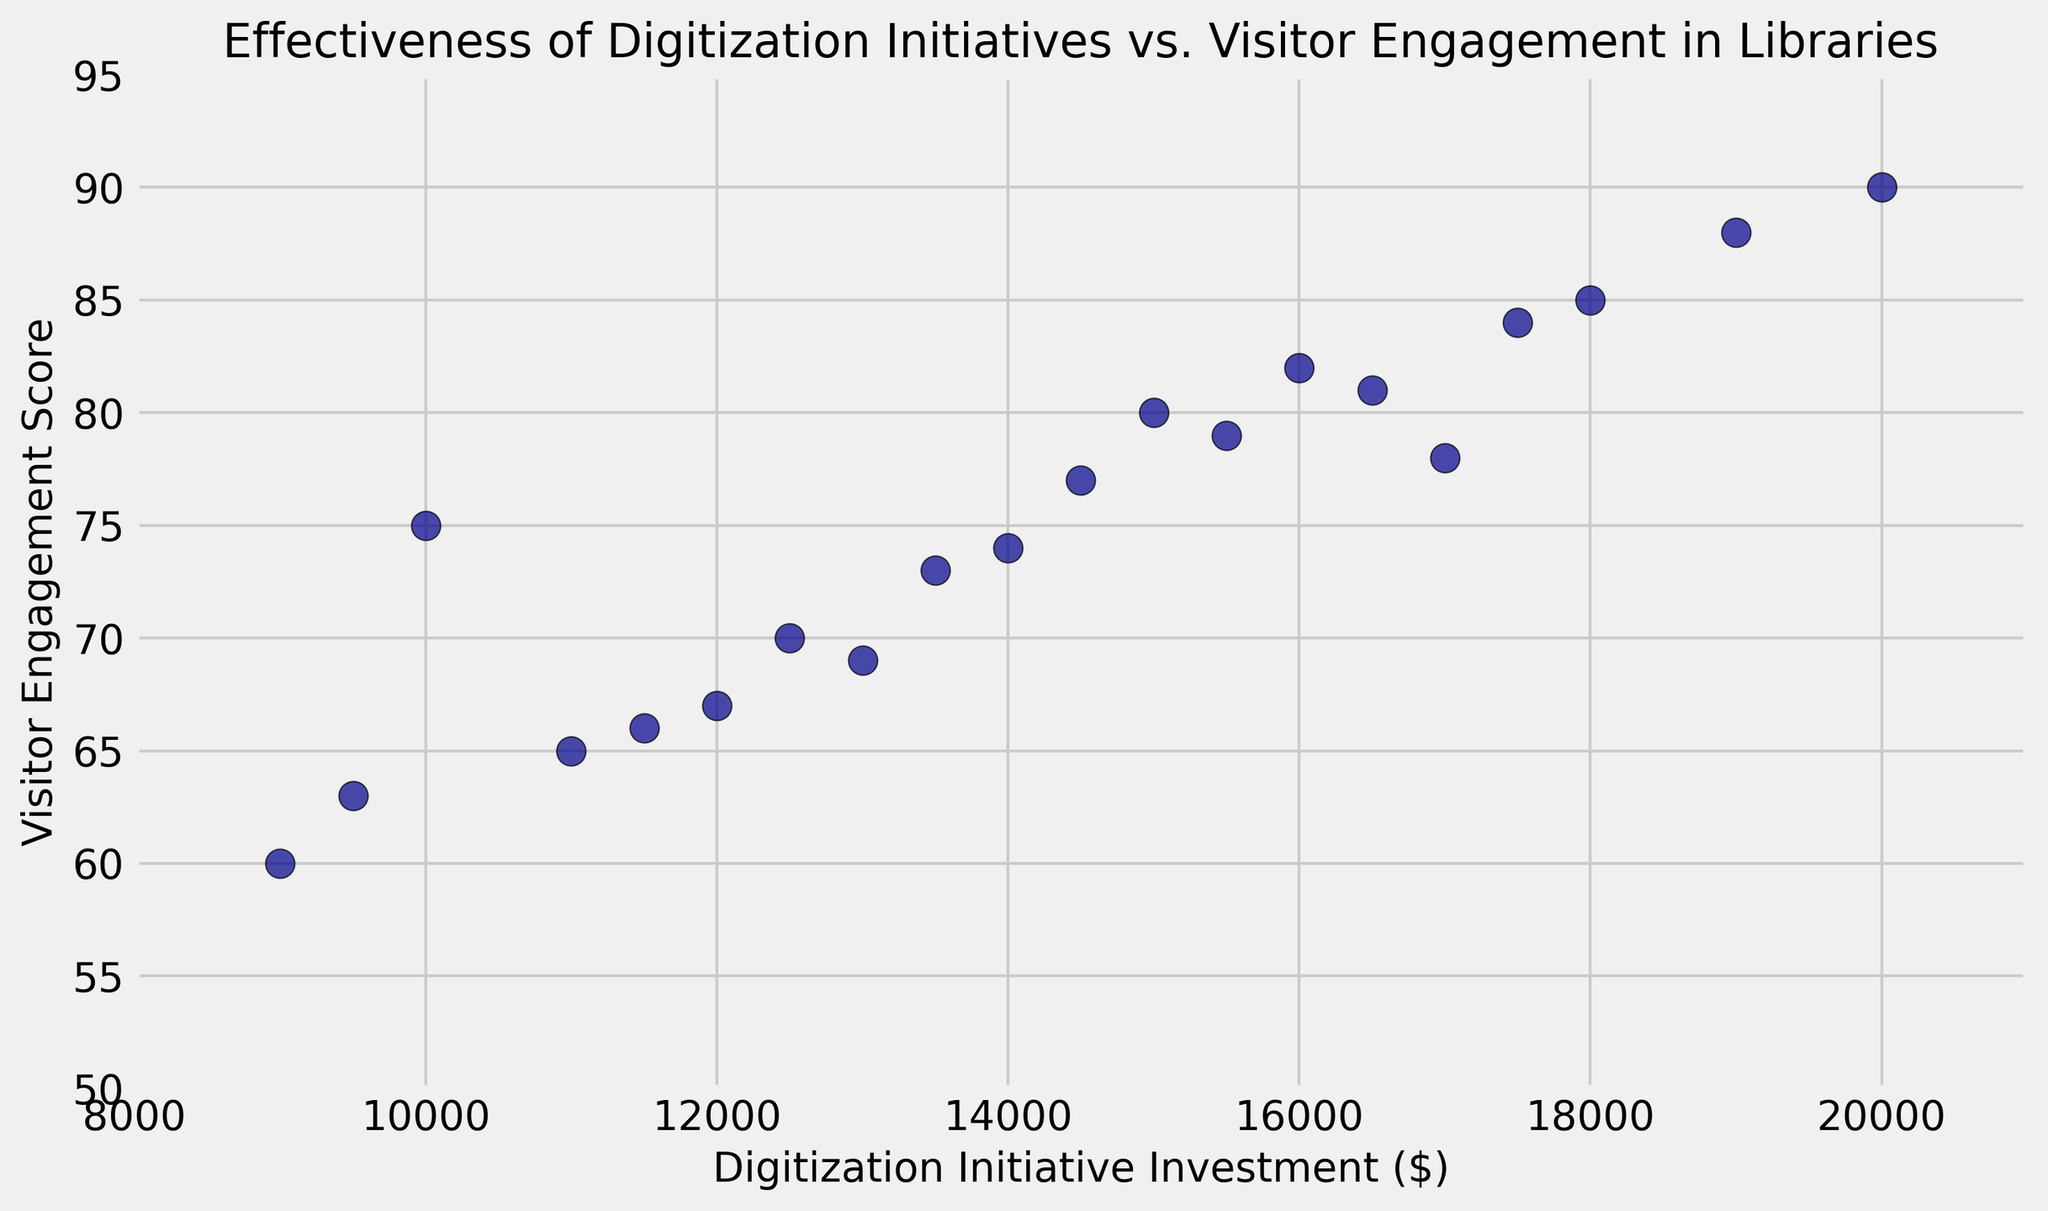What is the range of Visitor Engagement Scores in the figure? The range is the difference between the maximum and minimum Visitor Engagement Scores. The highest Visitor Engagement Score is 90, and the lowest is 60. So, the range is 90 - 60.
Answer: 30 What is the average Digitization Initiative Investment? To find the average, sum all the Digitization Initiative Investment values and divide by the number of data points. The sum of the investments is 278500, and there are 20 data points. So, 278500 / 20 = 13925.
Answer: 13925 Which data point represents the highest Visitor Engagement Score, and what is its corresponding investment? The highest Visitor Engagement Score is 90. The corresponding Digitization Initiative Investment for this score is 20000.
Answer: 20000 and 90 Are there any data points where the Visitor Engagement Score is below the average score? First, calculate the average Visitor Engagement Score: sum all scores (1632) and divide by the number of data points (20), which is 1632 / 20 = 81.6. Then identify points below this average in the figure.
Answer: Yes How many data points have a Visitor Engagement Score greater than 80? Count all points with a Visitor Engagement Score above 80 by inspecting the y-axis values in the figure.
Answer: 8 What is the median Digitization Initiative Investment? To find the median, sort all the investment values and find the middle one. For 20 data points, the median is the average of the 10th and 11th values. Sorted investments: ...11500, 12000, 12500, 13000, 13500, 14000, 14500, 15000, 15500, 16000, 16500, 17000... The median is (14500 + 15500) / 2 = 15000.
Answer: 15000 Which data point has the smallest Digitization Initiative Investment? Inspect the x-axis values to find the smallest investment, which is 9000, and its corresponding score is 60.
Answer: 9000 and 60 Is there a visible correlation between Digitization Initiative Investment and Visitor Engagement Score? Observing the scatter plot shows that as the Digitization Initiative Investment increases, the Visitor Engagement Score tends to increase. This indicates a positive correlation.
Answer: Yes, positive What is the difference between the highest and lowest Digitization Initiative Investments? Subtract the lowest investment (9000) from the highest (20000). So, 20000 - 9000 = 11000.
Answer: 11000 Is there any data point where Digitization Initiative Investment and Visitor Engagement Score are both above their respective averages? The average investment is 13925 and the average engagement score is 81.6. Check which points fulfill both criteria by inspecting the figure.
Answer: Yes 